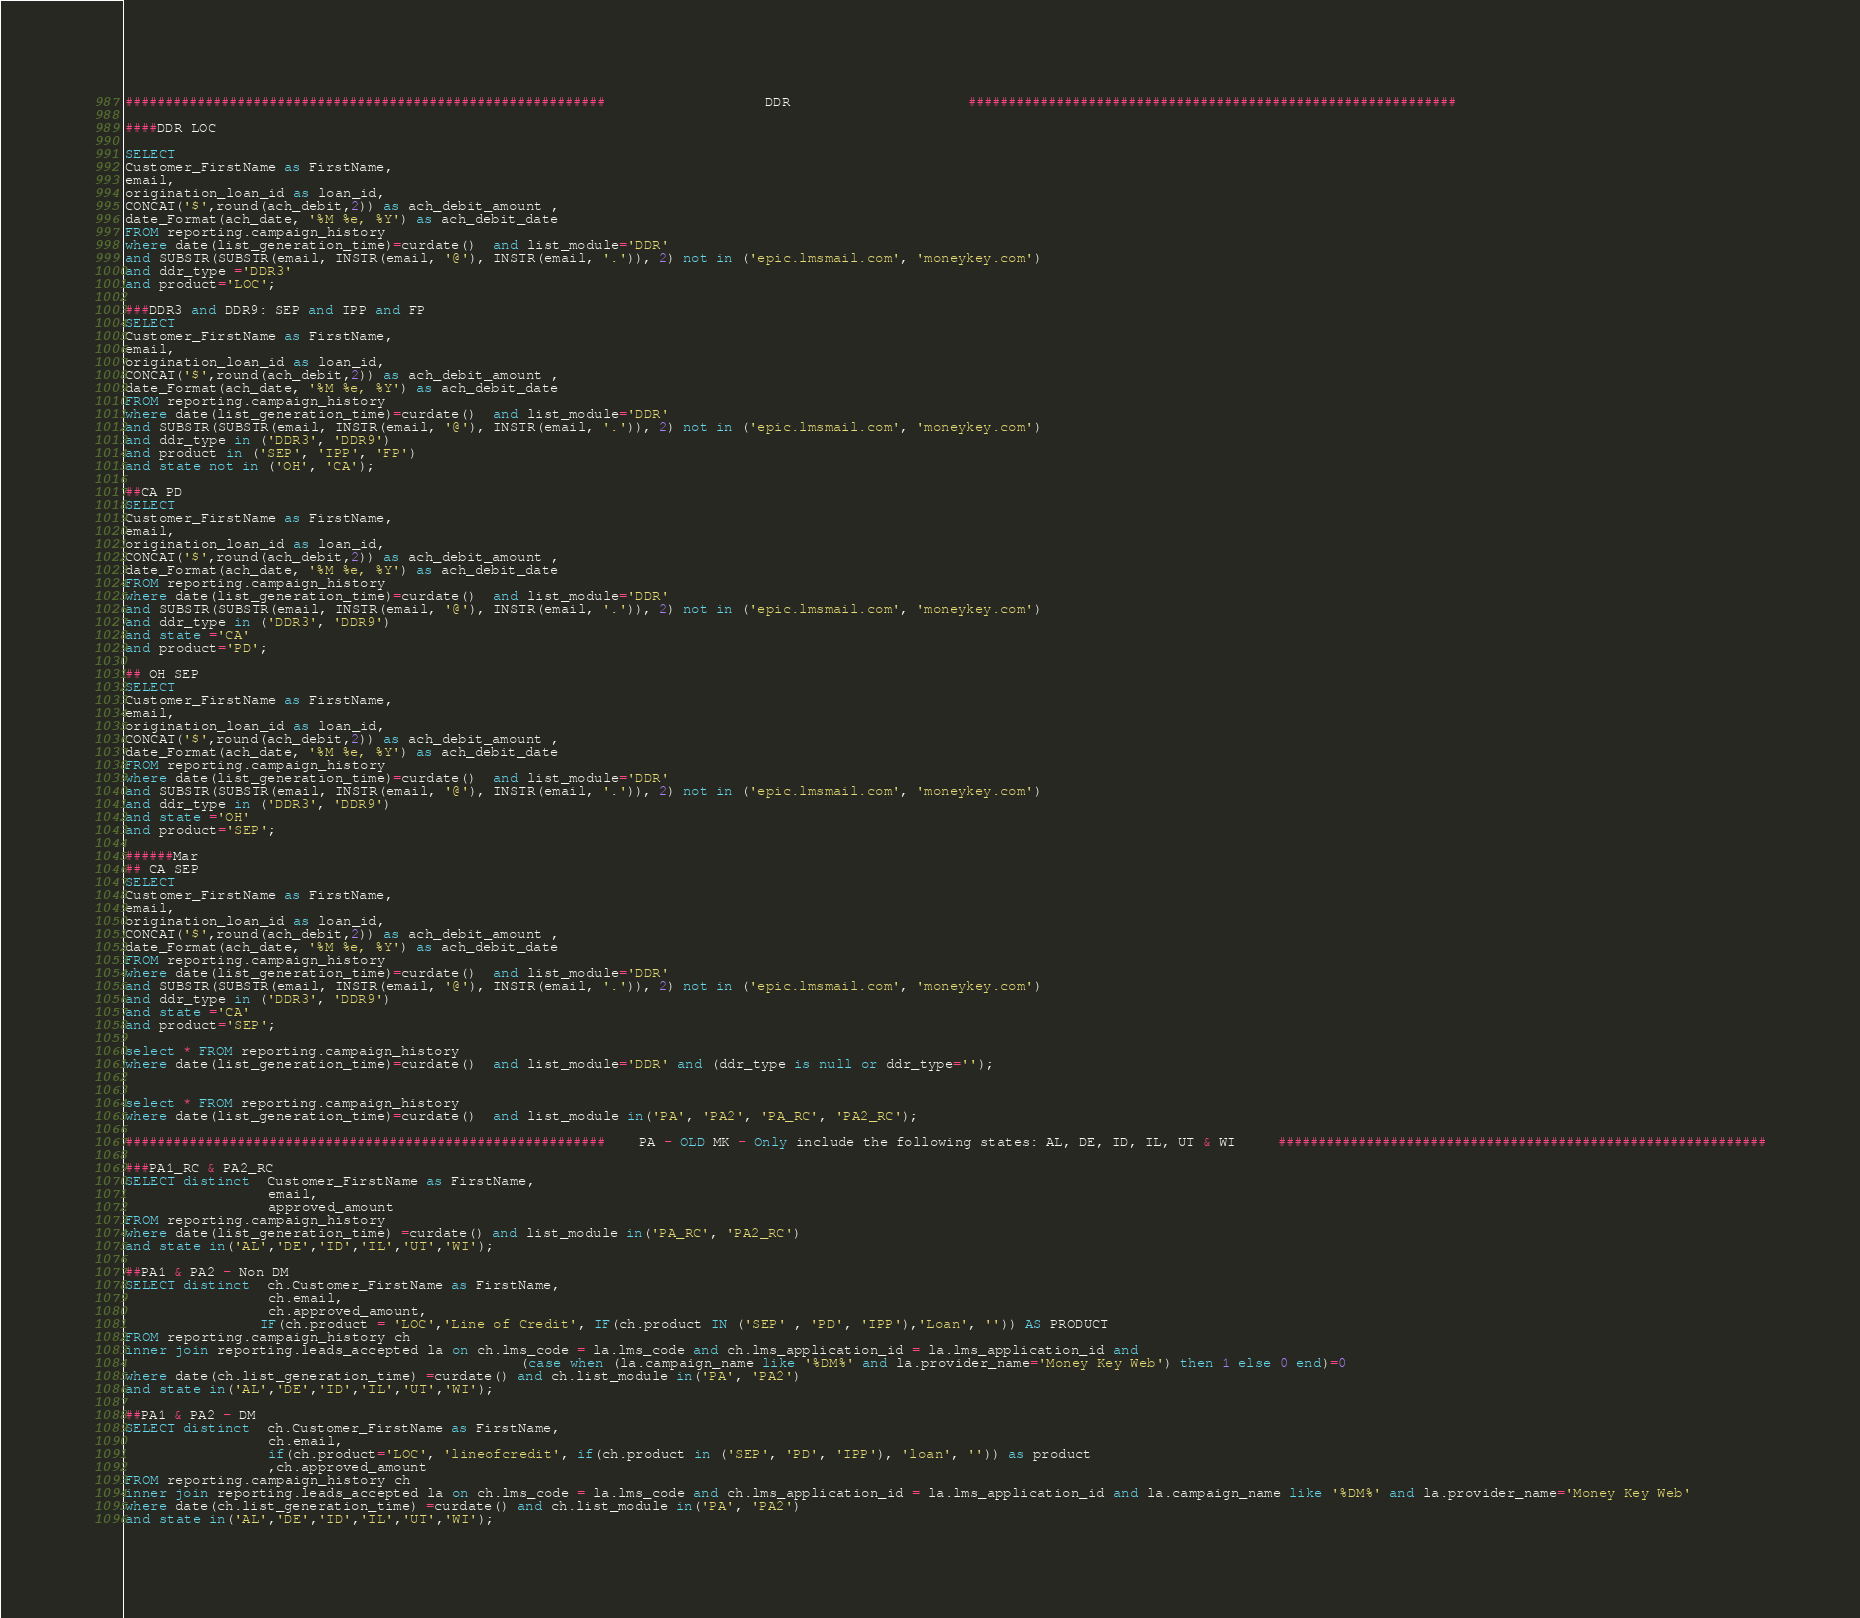Convert code to text. <code><loc_0><loc_0><loc_500><loc_500><_SQL_>

############################################################                   DDR                     #############################################################

####DDR LOC

SELECT  
Customer_FirstName as FirstName,
email,
origination_loan_id as loan_id, 
CONCAT('$',round(ach_debit,2)) as ach_debit_amount , 
date_Format(ach_date, '%M %e, %Y') as ach_debit_date 
FROM reporting.campaign_history
where date(list_generation_time)=curdate()  and list_module='DDR'
and SUBSTR(SUBSTR(email, INSTR(email, '@'), INSTR(email, '.')), 2) not in ('epic.lmsmail.com', 'moneykey.com')
and ddr_type ='DDR3'
and product='LOC';

###DDR3 and DDR9: SEP and IPP and FP
SELECT 
Customer_FirstName as FirstName,
email,
origination_loan_id as loan_id, 
CONCAT('$',round(ach_debit,2)) as ach_debit_amount , 
date_Format(ach_date, '%M %e, %Y') as ach_debit_date 
FROM reporting.campaign_history
where date(list_generation_time)=curdate()  and list_module='DDR'
and SUBSTR(SUBSTR(email, INSTR(email, '@'), INSTR(email, '.')), 2) not in ('epic.lmsmail.com', 'moneykey.com')
and ddr_type in ('DDR3', 'DDR9')
and product in ('SEP', 'IPP', 'FP')
and state not in ('OH', 'CA');

##CA PD
SELECT 
Customer_FirstName as FirstName,
email,
origination_loan_id as loan_id, 
CONCAT('$',round(ach_debit,2)) as ach_debit_amount , 
date_Format(ach_date, '%M %e, %Y') as ach_debit_date 
FROM reporting.campaign_history
where date(list_generation_time)=curdate()  and list_module='DDR'
and SUBSTR(SUBSTR(email, INSTR(email, '@'), INSTR(email, '.')), 2) not in ('epic.lmsmail.com', 'moneykey.com')
and ddr_type in ('DDR3', 'DDR9')
and state ='CA'
and product='PD';

## OH SEP
SELECT  
Customer_FirstName as FirstName,
email,
origination_loan_id as loan_id, 
CONCAT('$',round(ach_debit,2)) as ach_debit_amount , 
date_Format(ach_date, '%M %e, %Y') as ach_debit_date 
FROM reporting.campaign_history
where date(list_generation_time)=curdate()  and list_module='DDR'
and SUBSTR(SUBSTR(email, INSTR(email, '@'), INSTR(email, '.')), 2) not in ('epic.lmsmail.com', 'moneykey.com')
and ddr_type in ('DDR3', 'DDR9')
and state ='OH'
and product='SEP';

######Mar
## CA SEP
SELECT  
Customer_FirstName as FirstName,
email,
origination_loan_id as loan_id, 
CONCAT('$',round(ach_debit,2)) as ach_debit_amount , 
date_Format(ach_date, '%M %e, %Y') as ach_debit_date 
FROM reporting.campaign_history
where date(list_generation_time)=curdate()  and list_module='DDR'
and SUBSTR(SUBSTR(email, INSTR(email, '@'), INSTR(email, '.')), 2) not in ('epic.lmsmail.com', 'moneykey.com')
and ddr_type in ('DDR3', 'DDR9')
and state ='CA'
and product='SEP';

select * FROM reporting.campaign_history
where date(list_generation_time)=curdate()  and list_module='DDR' and (ddr_type is null or ddr_type='');


select * FROM reporting.campaign_history
where date(list_generation_time)=curdate()  and list_module in('PA', 'PA2', 'PA_RC', 'PA2_RC');

############################################################    PA - OLD MK - Only include the following states: AL, DE, ID, IL, UT & WI     #############################################################

###PA1_RC & PA2_RC
SELECT distinct  Customer_FirstName as FirstName, 
                 email,
                 approved_amount
FROM reporting.campaign_history 
where date(list_generation_time) =curdate() and list_module in('PA_RC', 'PA2_RC')
and state in('AL','DE','ID','IL','UT','WI');
 
##PA1 & PA2 - Non DM 
SELECT distinct  ch.Customer_FirstName as FirstName, 
                 ch.email,
                 ch.approved_amount,
                IF(ch.product = 'LOC','Line of Credit', IF(ch.product IN ('SEP' , 'PD', 'IPP'),'Loan', '')) AS PRODUCT
FROM reporting.campaign_history ch
inner join reporting.leads_accepted la on ch.lms_code = la.lms_code and ch.lms_application_id = la.lms_application_id and 
                                               (case when (la.campaign_name like '%DM%' and la.provider_name='Money Key Web') then 1 else 0 end)=0                                            
where date(ch.list_generation_time) =curdate() and ch.list_module in('PA', 'PA2')
and state in('AL','DE','ID','IL','UT','WI');

##PA1 & PA2 - DM
SELECT distinct  ch.Customer_FirstName as FirstName, 
                 ch.email,
                 if(ch.product='LOC', 'lineofcredit', if(ch.product in ('SEP', 'PD', 'IPP'), 'loan', '')) as product
                 ,ch.approved_amount
FROM reporting.campaign_history ch
inner join reporting.leads_accepted la on ch.lms_code = la.lms_code and ch.lms_application_id = la.lms_application_id and la.campaign_name like '%DM%' and la.provider_name='Money Key Web'
where date(ch.list_generation_time) =curdate() and ch.list_module in('PA', 'PA2')
and state in('AL','DE','ID','IL','UT','WI');


</code> 